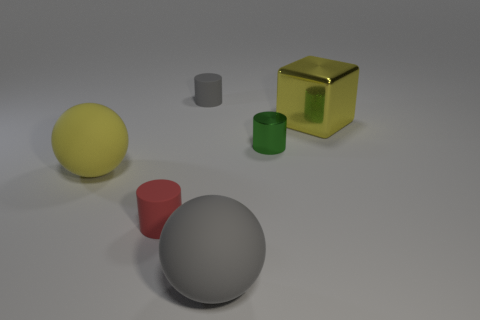Do the matte ball that is to the left of the large gray rubber thing and the cube have the same color?
Keep it short and to the point. Yes. Does the small rubber object that is behind the big metal cube have the same color as the large sphere in front of the tiny red matte cylinder?
Offer a terse response. Yes. How many other things are there of the same color as the large metal thing?
Keep it short and to the point. 1. Is the number of rubber spheres that are to the right of the tiny gray rubber cylinder the same as the number of green cylinders that are to the right of the yellow rubber object?
Provide a short and direct response. Yes. Is there a gray cylinder that has the same material as the large gray thing?
Keep it short and to the point. Yes. Do the gray ball and the large cube have the same material?
Ensure brevity in your answer.  No. How many green things are either shiny things or balls?
Ensure brevity in your answer.  1. Is the number of cylinders that are left of the tiny gray rubber cylinder greater than the number of big cyan rubber spheres?
Your answer should be compact. Yes. Are there any big rubber spheres that have the same color as the large metallic block?
Your answer should be very brief. Yes. What size is the yellow rubber sphere?
Provide a short and direct response. Large. 